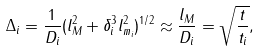Convert formula to latex. <formula><loc_0><loc_0><loc_500><loc_500>\Delta _ { i } = \frac { 1 } { D _ { i } } ( l ^ { 2 } _ { M } + \delta ^ { 3 } _ { i } l ^ { 2 } _ { m _ { i } } ) ^ { 1 / 2 } \approx \frac { l _ { M } } { D _ { i } } = \sqrt { \frac { t } { t _ { i } } } ,</formula> 